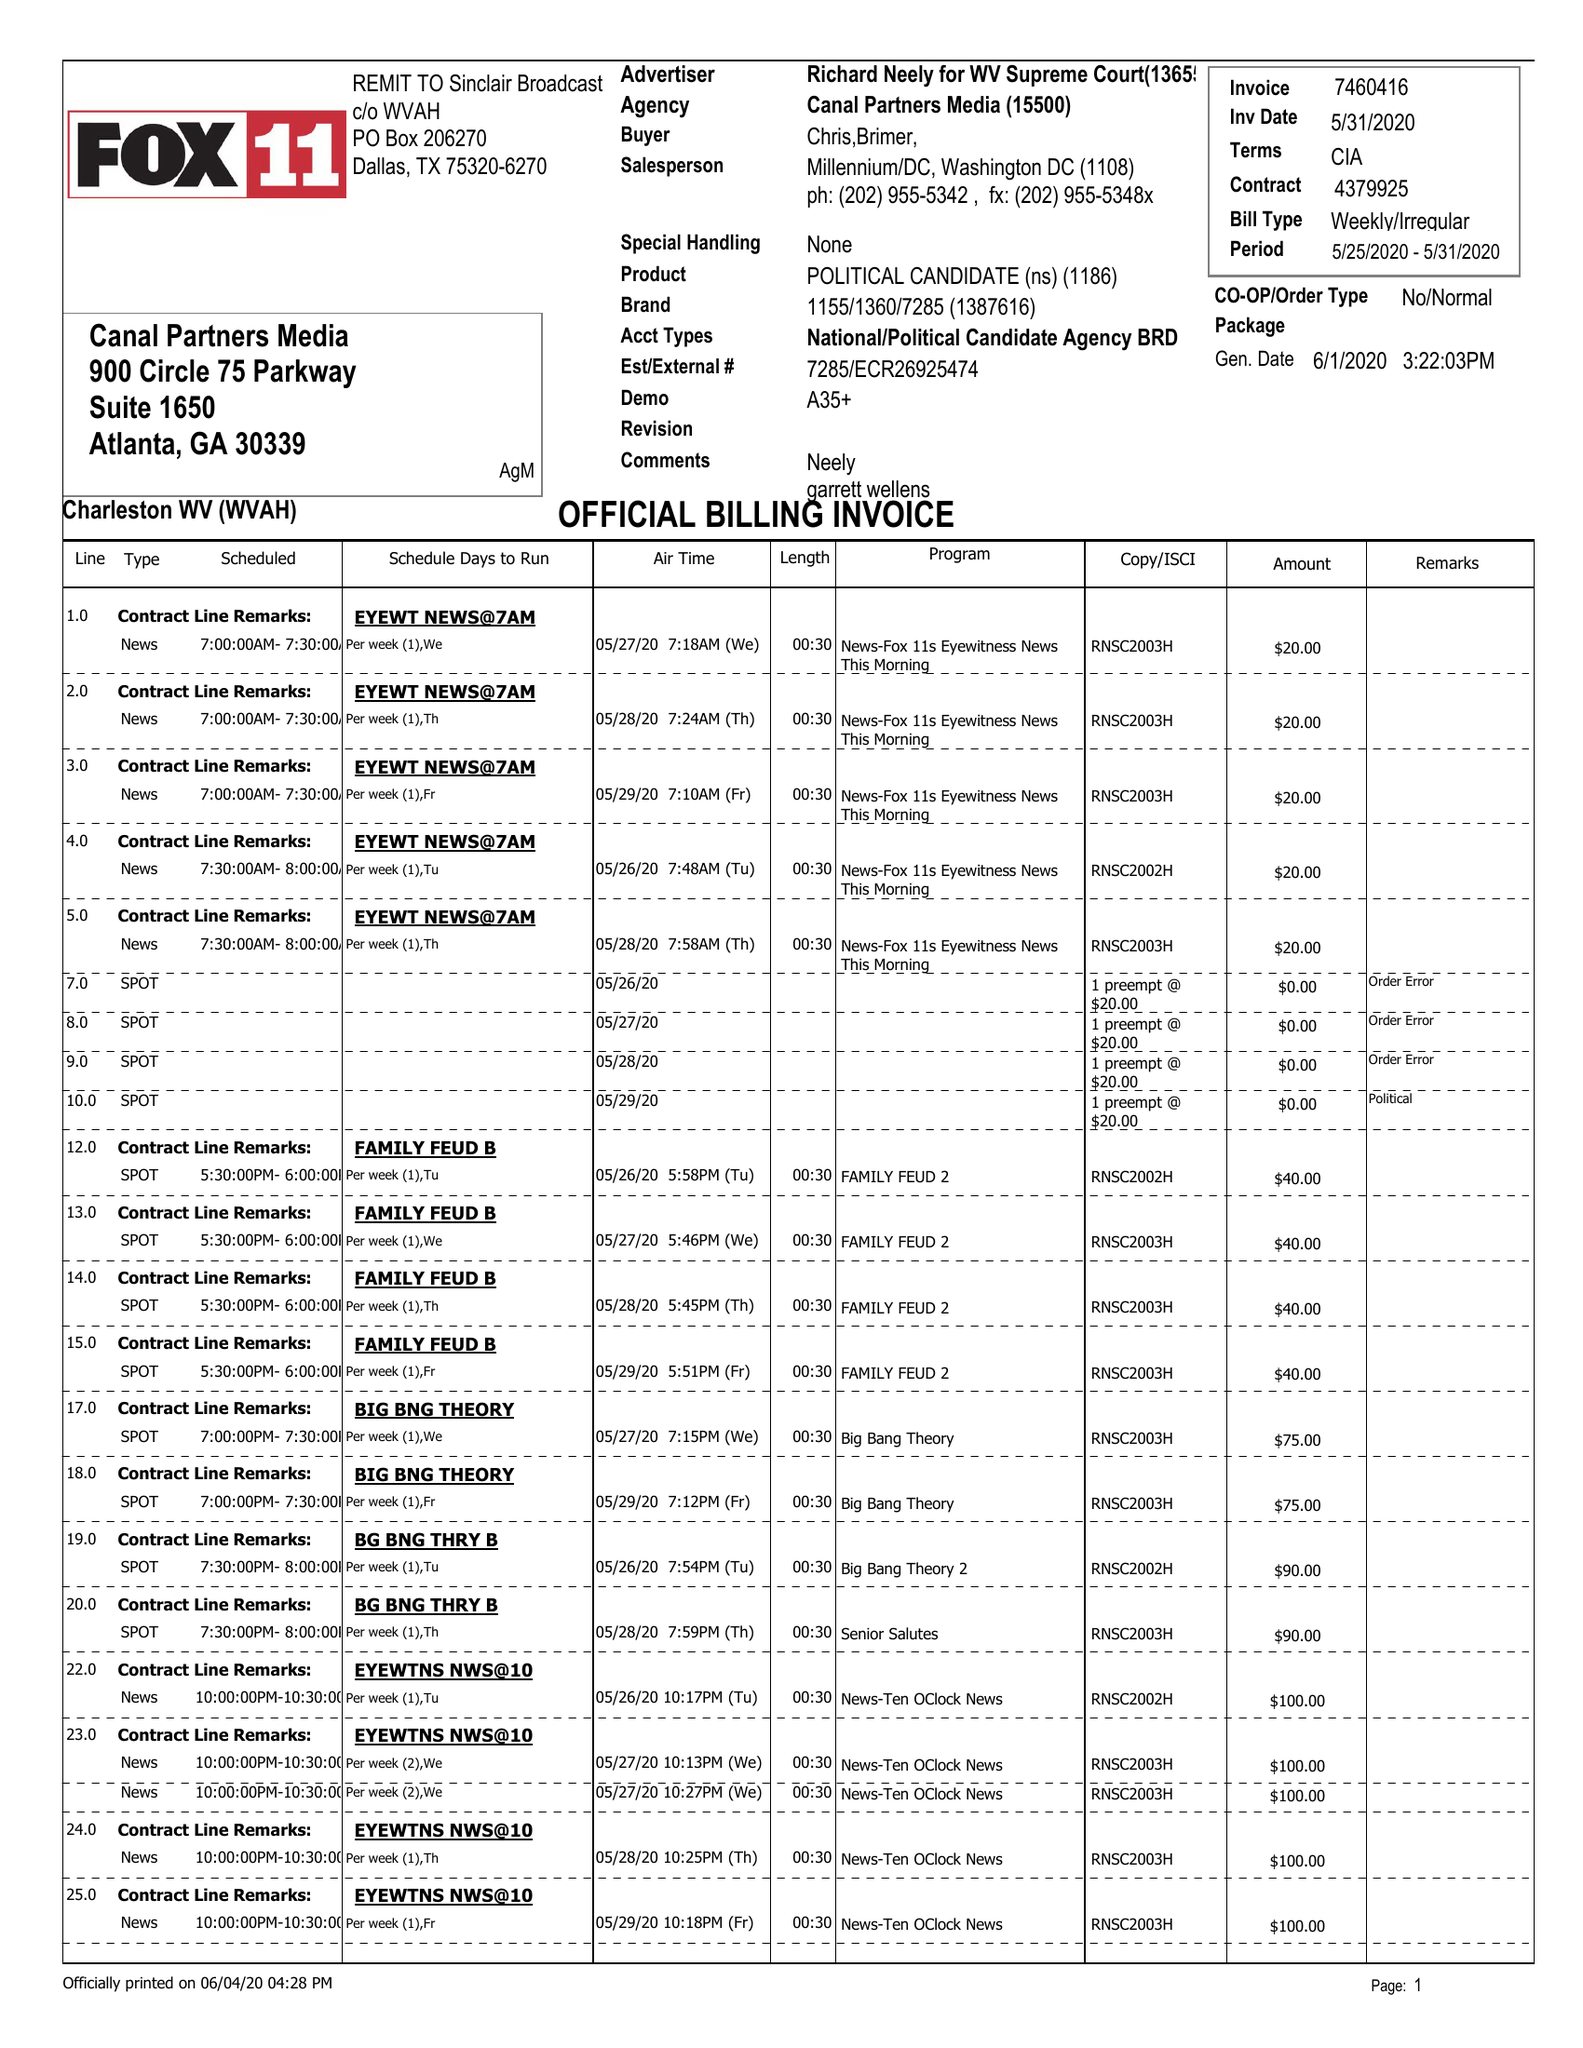What is the value for the flight_to?
Answer the question using a single word or phrase. 05/31/20 